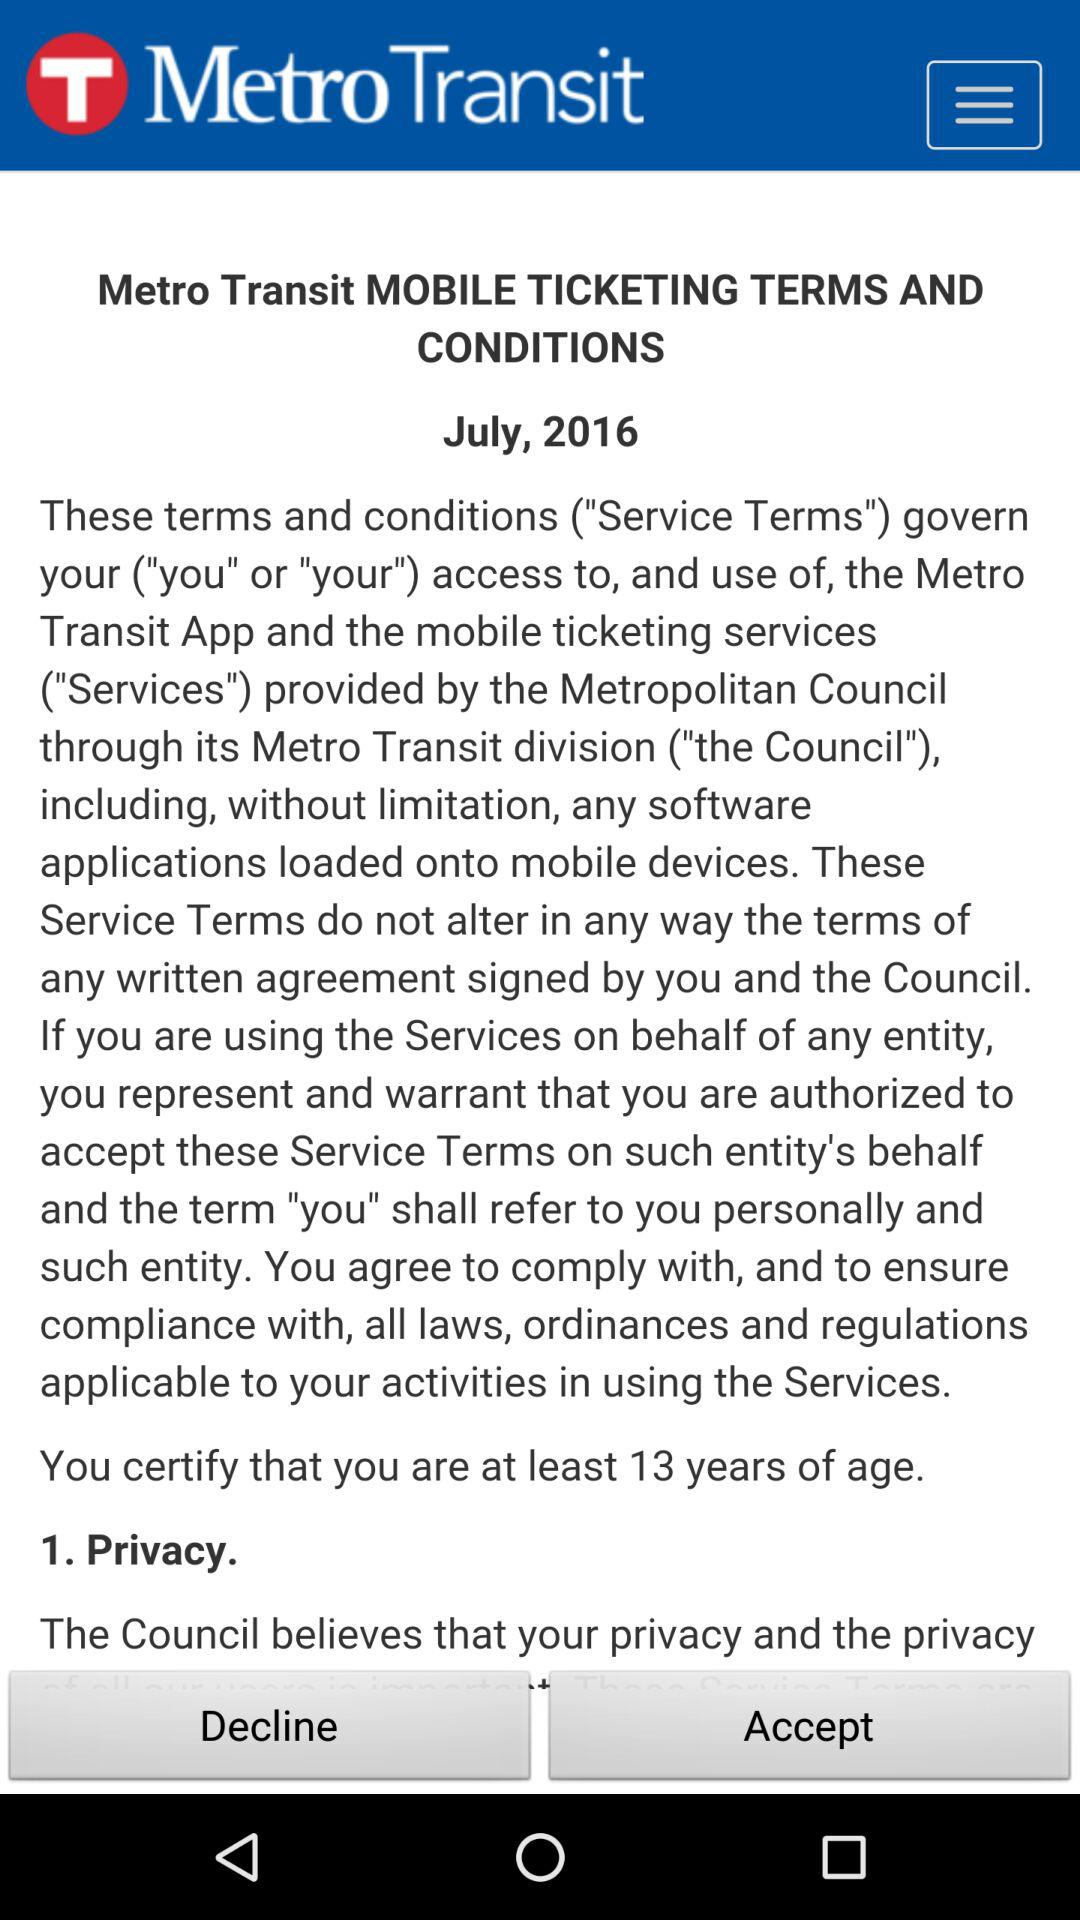What is the application name? The application name is "Metro Transit". 